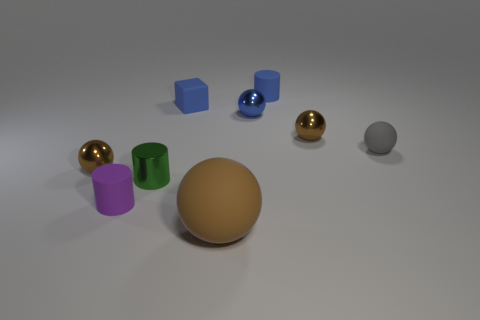How many objects are there, and can you describe their shapes? In the image, there are a total of eight objects. There are two cubes, three spheres, and three cylinders. The objects vary in color, each bearing its own distinct hue, and are scattered across a flat surface. 